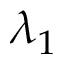Convert formula to latex. <formula><loc_0><loc_0><loc_500><loc_500>\lambda _ { 1 }</formula> 